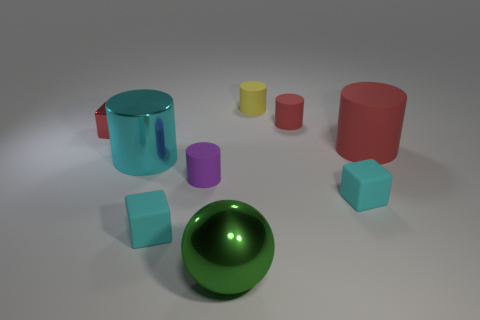How many other purple rubber cylinders have the same size as the purple cylinder?
Keep it short and to the point. 0. The large thing right of the matte cube right of the yellow matte cylinder is what shape?
Give a very brief answer. Cylinder. Is the number of tiny blue things less than the number of tiny cyan rubber cubes?
Provide a short and direct response. Yes. There is a small thing left of the cyan shiny cylinder; what is its color?
Make the answer very short. Red. What material is the small cylinder that is both to the right of the large shiny ball and in front of the yellow cylinder?
Make the answer very short. Rubber. What is the shape of the tiny red thing that is made of the same material as the small purple object?
Your response must be concise. Cylinder. What number of green things are on the right side of the red cylinder that is behind the small metal object?
Keep it short and to the point. 0. What number of objects are both left of the big matte object and to the right of the small metallic thing?
Your answer should be compact. 7. What number of other things are the same material as the small purple object?
Offer a terse response. 5. There is a big cylinder on the left side of the rubber cube on the right side of the small red matte thing; what is its color?
Your answer should be compact. Cyan. 